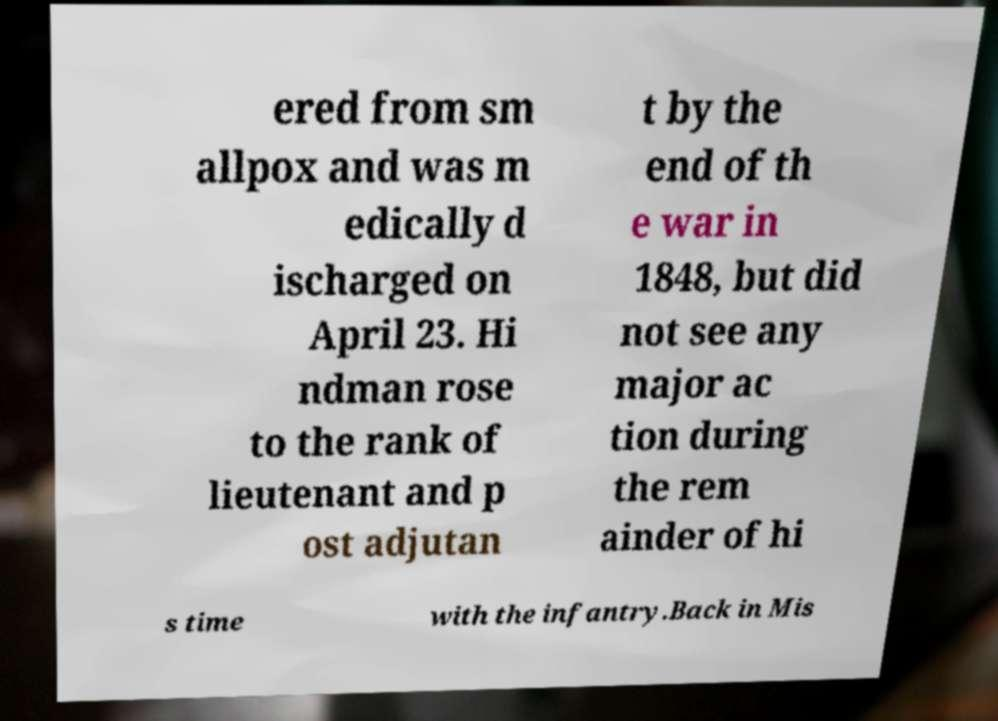Can you accurately transcribe the text from the provided image for me? ered from sm allpox and was m edically d ischarged on April 23. Hi ndman rose to the rank of lieutenant and p ost adjutan t by the end of th e war in 1848, but did not see any major ac tion during the rem ainder of hi s time with the infantry.Back in Mis 